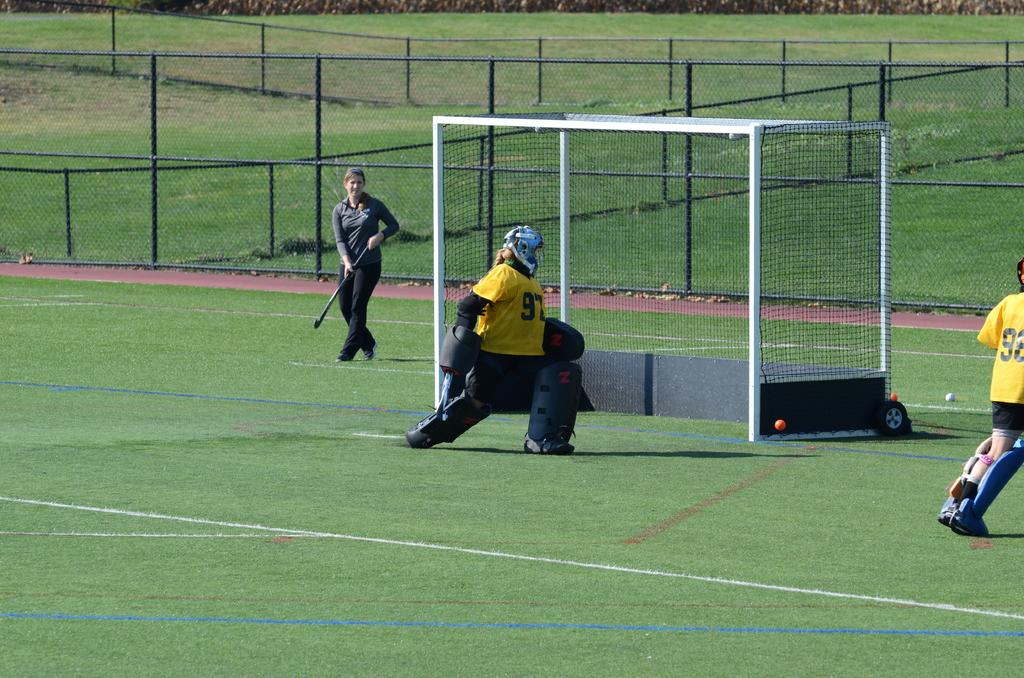<image>
Present a compact description of the photo's key features. Lacrosse game being played on a field, the goalie is # 97. 